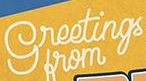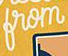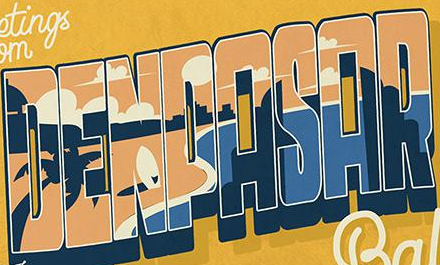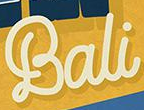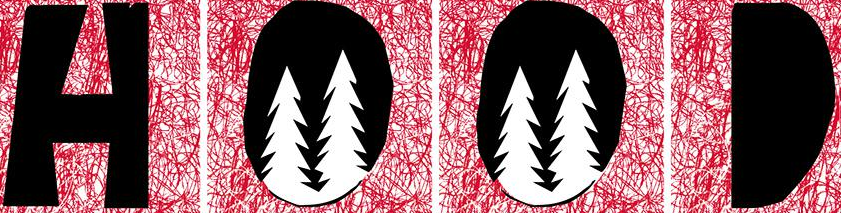What text appears in these images from left to right, separated by a semicolon? greetings; from; DENPASAR; Bali; HOOD 